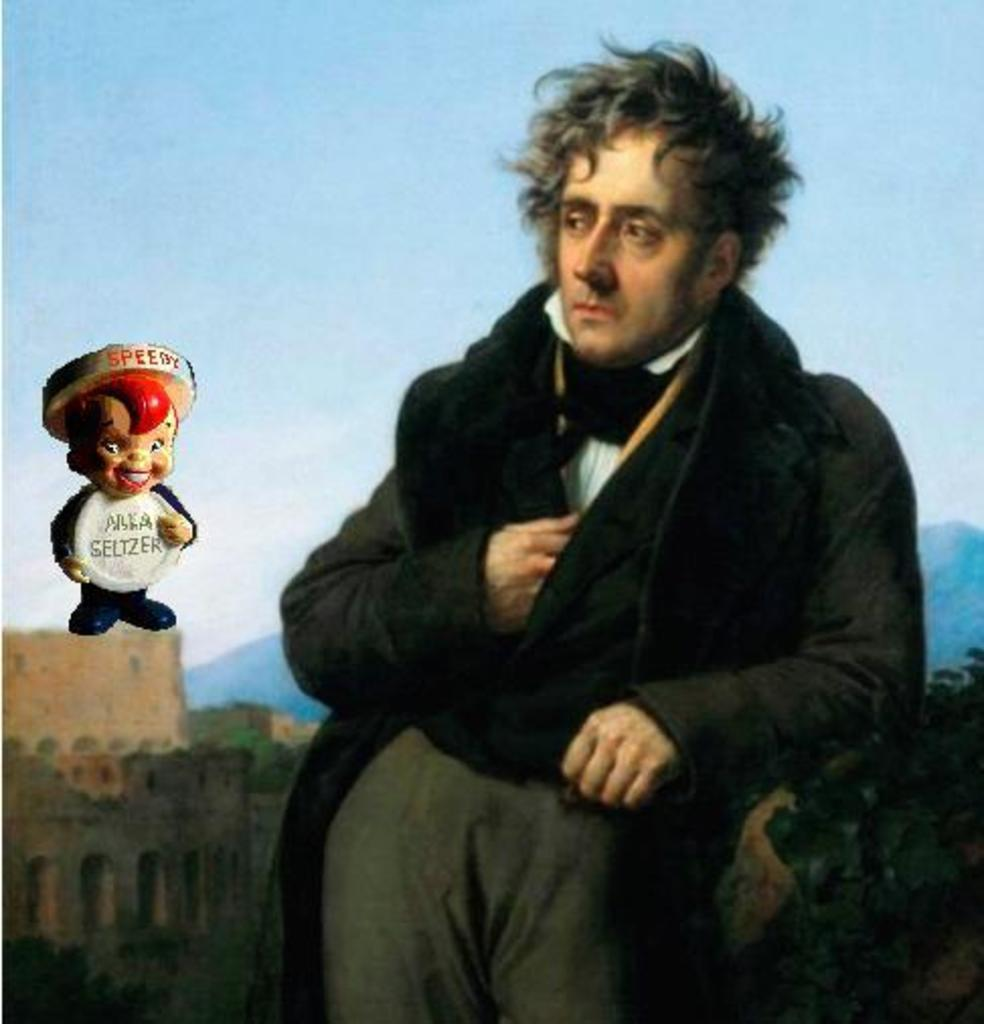Who is present in the image? There is a man in the image. What is located beside the man? There is an animation image beside the man. What can be seen in the background of the image? There are forts visible in the background of the image. What type of property does the man's dad own in the image? There is no mention of a dad or any property in the image. 